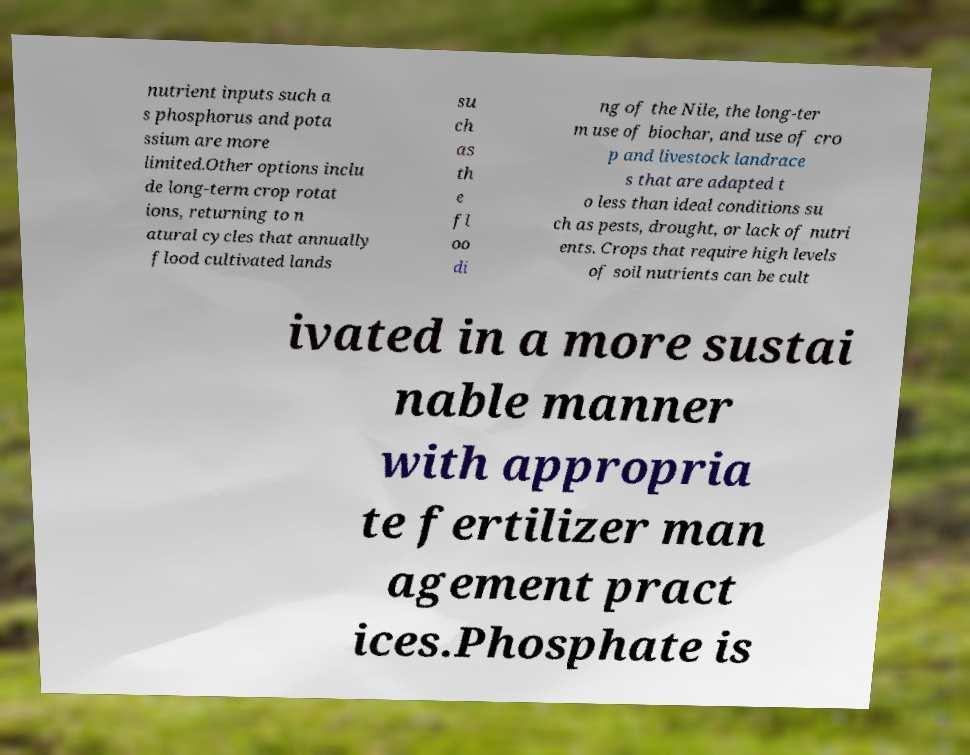I need the written content from this picture converted into text. Can you do that? nutrient inputs such a s phosphorus and pota ssium are more limited.Other options inclu de long-term crop rotat ions, returning to n atural cycles that annually flood cultivated lands su ch as th e fl oo di ng of the Nile, the long-ter m use of biochar, and use of cro p and livestock landrace s that are adapted t o less than ideal conditions su ch as pests, drought, or lack of nutri ents. Crops that require high levels of soil nutrients can be cult ivated in a more sustai nable manner with appropria te fertilizer man agement pract ices.Phosphate is 